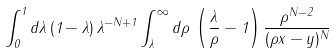<formula> <loc_0><loc_0><loc_500><loc_500>\int _ { 0 } ^ { 1 } d \lambda \, ( 1 - \lambda ) \, \lambda ^ { - N + 1 } \int _ { \lambda } ^ { \infty } d \rho \, \left ( \frac { \lambda } { \rho } - 1 \right ) \frac { \rho ^ { N - 2 } } { ( \rho x - y ) ^ { N } }</formula> 